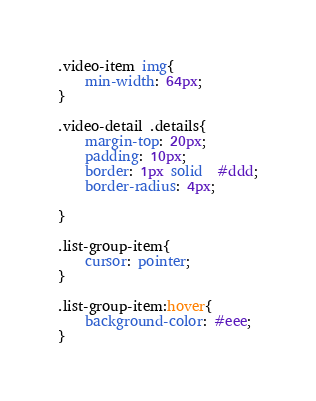<code> <loc_0><loc_0><loc_500><loc_500><_CSS_>
.video-item img{
    min-width: 64px;
}

.video-detail .details{
    margin-top: 20px;
    padding: 10px;
    border: 1px solid  #ddd;
    border-radius: 4px;

}

.list-group-item{
    cursor: pointer;
}

.list-group-item:hover{
    background-color: #eee;
}</code> 